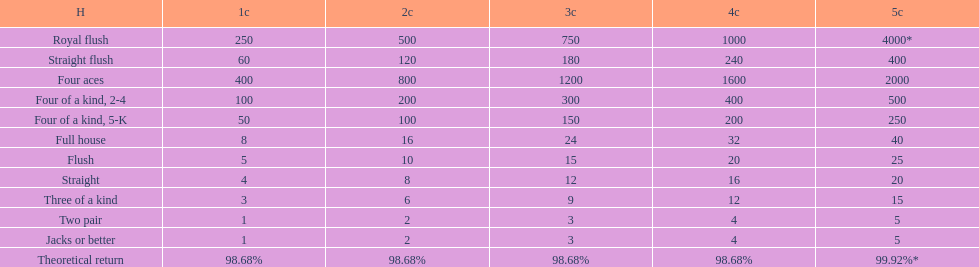Which hand is the top hand in the card game super aces? Royal flush. 